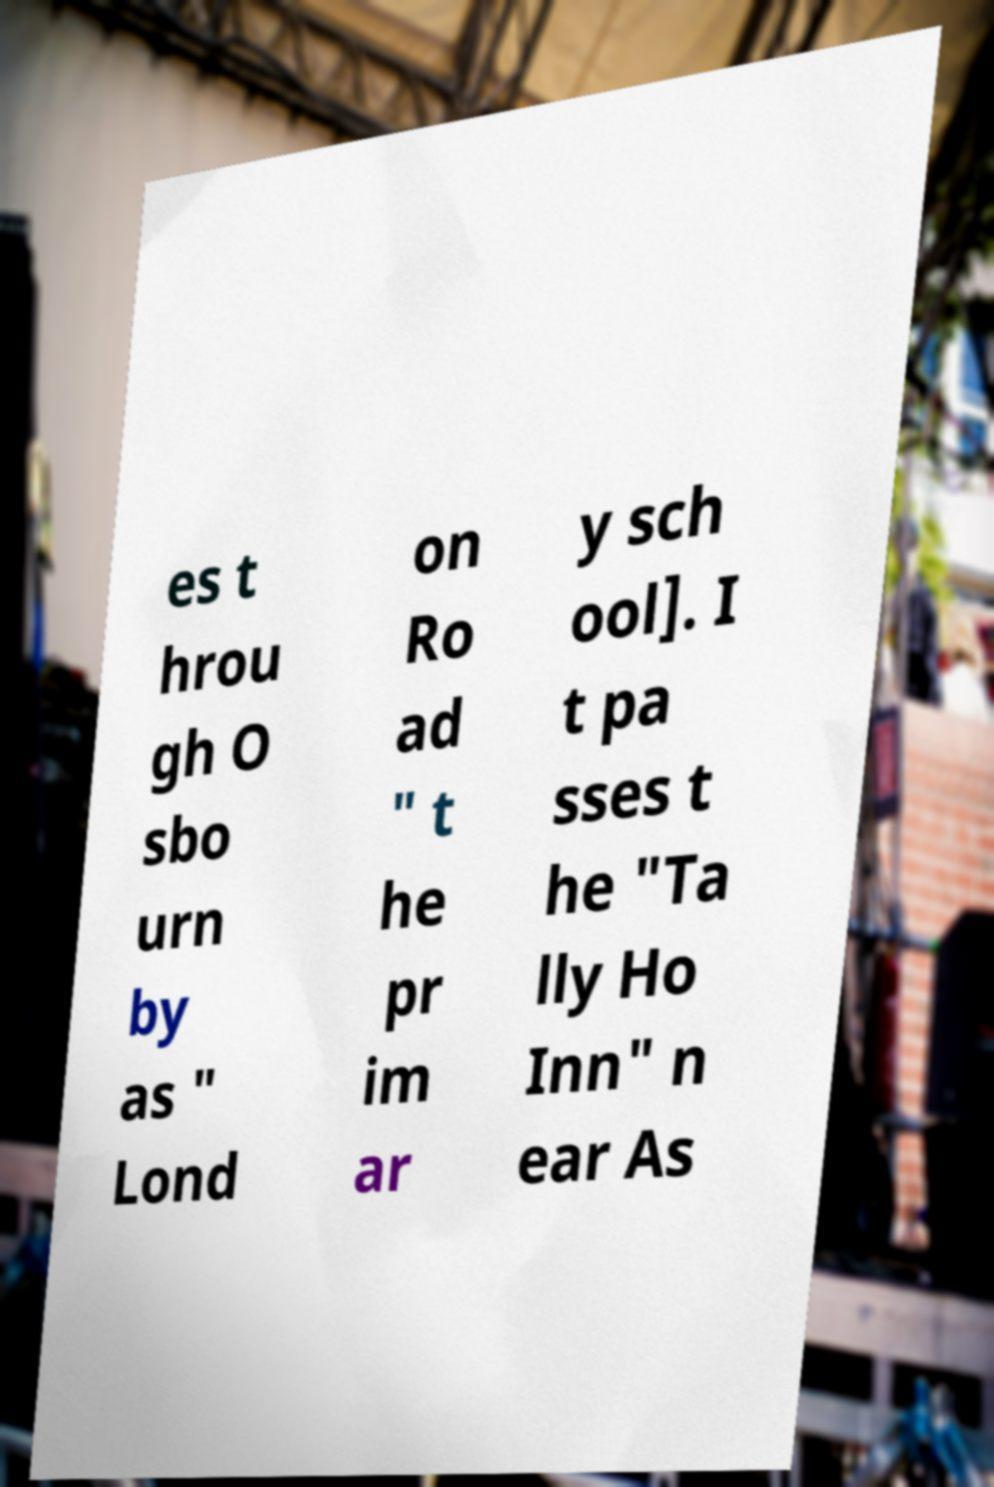Please read and relay the text visible in this image. What does it say? es t hrou gh O sbo urn by as " Lond on Ro ad " t he pr im ar y sch ool]. I t pa sses t he "Ta lly Ho Inn" n ear As 